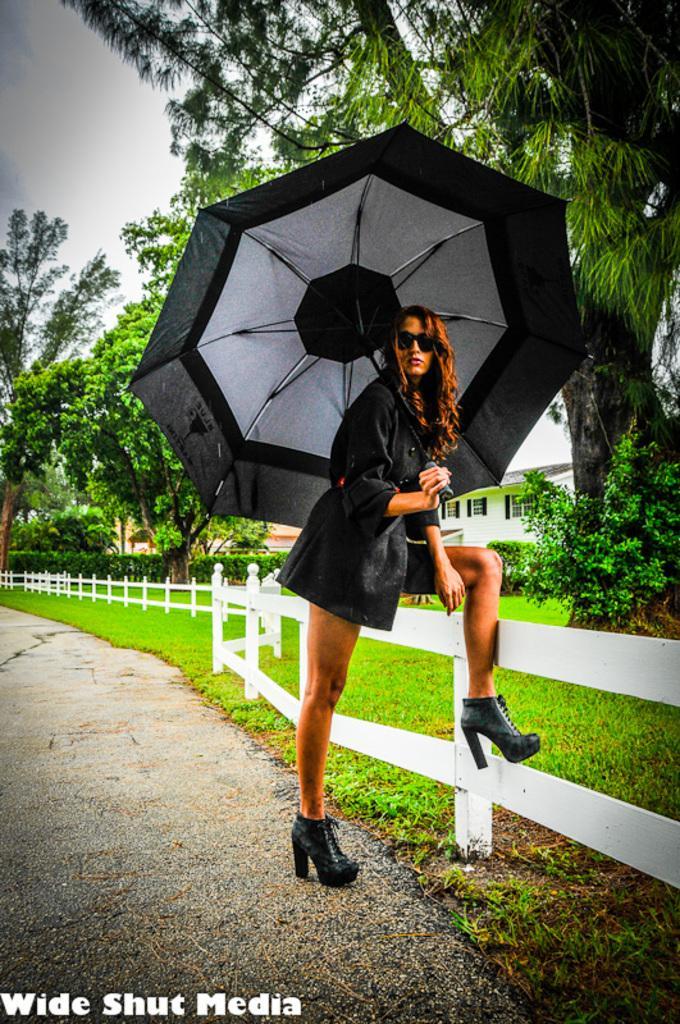How would you summarize this image in a sentence or two? In this image we can see a woman standing on the ground holding an umbrella. We can also see some grass, a fence, plants, trees, a building and the sky which looks cloudy. 